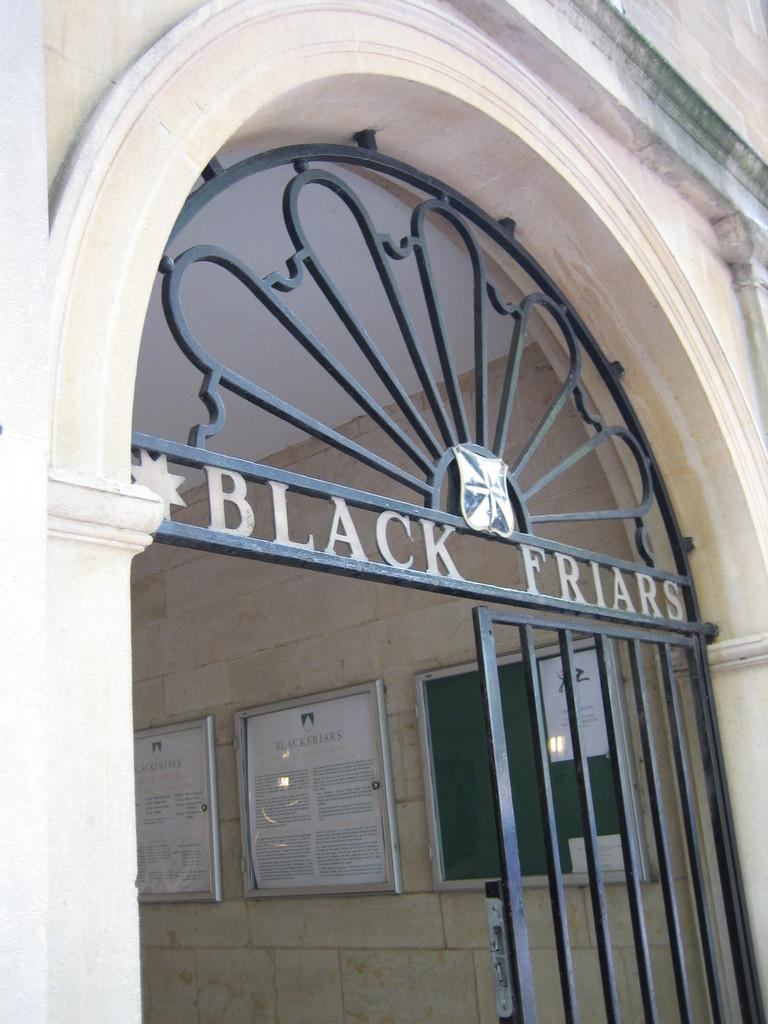What type of structure is present in the image? There is a gate in the image. What other architectural feature can be seen in the image? There is an arch in the image. What type of material is used for the walls in the image? There are stone walls in the image. What can be seen placed in the background of the image? There are a few boards placed in the background of the image. Can you tell me how the tramp is used to play in the image? There is no tramp present in the image. How do the people in the image join together to form a group? There are no people present in the image. 